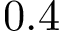Convert formula to latex. <formula><loc_0><loc_0><loc_500><loc_500>0 . 4</formula> 